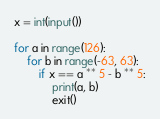Convert code to text. <code><loc_0><loc_0><loc_500><loc_500><_Python_>x = int(input()) 

for a in range(126):
    for b in range(-63, 63):
        if x == a ** 5 - b ** 5:
            print(a, b)
            exit() </code> 